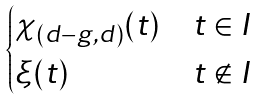<formula> <loc_0><loc_0><loc_500><loc_500>\begin{cases} \chi _ { ( d - g , d ) } ( t ) & t \in I \\ \xi ( t ) & t \notin I \end{cases}</formula> 